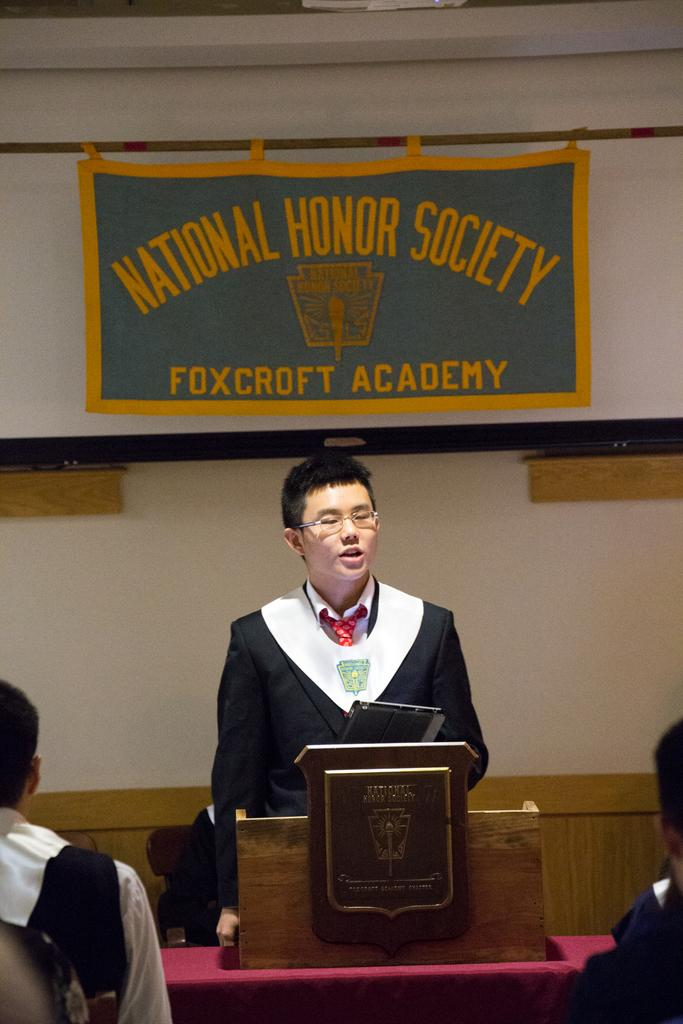What is the person in the image doing at the desk? The person is standing at a desk and holding a tablet. What can be seen in the background of the image? There is a banner and a wall visible in the background of the image. Are there any other people in the image? Yes, there are persons at the bottom of the image. What type of egg is being questioned by the person in the image? There is no egg present in the image, and the person is not questioning anything related to an egg. 